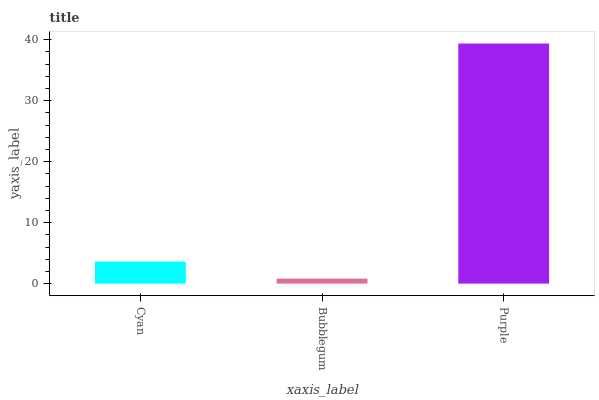Is Purple the minimum?
Answer yes or no. No. Is Bubblegum the maximum?
Answer yes or no. No. Is Purple greater than Bubblegum?
Answer yes or no. Yes. Is Bubblegum less than Purple?
Answer yes or no. Yes. Is Bubblegum greater than Purple?
Answer yes or no. No. Is Purple less than Bubblegum?
Answer yes or no. No. Is Cyan the high median?
Answer yes or no. Yes. Is Cyan the low median?
Answer yes or no. Yes. Is Bubblegum the high median?
Answer yes or no. No. Is Bubblegum the low median?
Answer yes or no. No. 